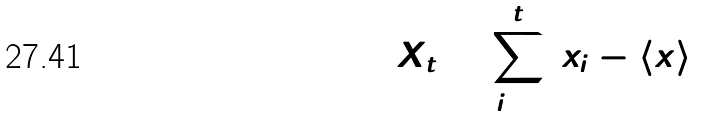<formula> <loc_0><loc_0><loc_500><loc_500>X _ { t } = \sum _ { i = 1 } ^ { t } ( x _ { i } - \langle x \rangle )</formula> 